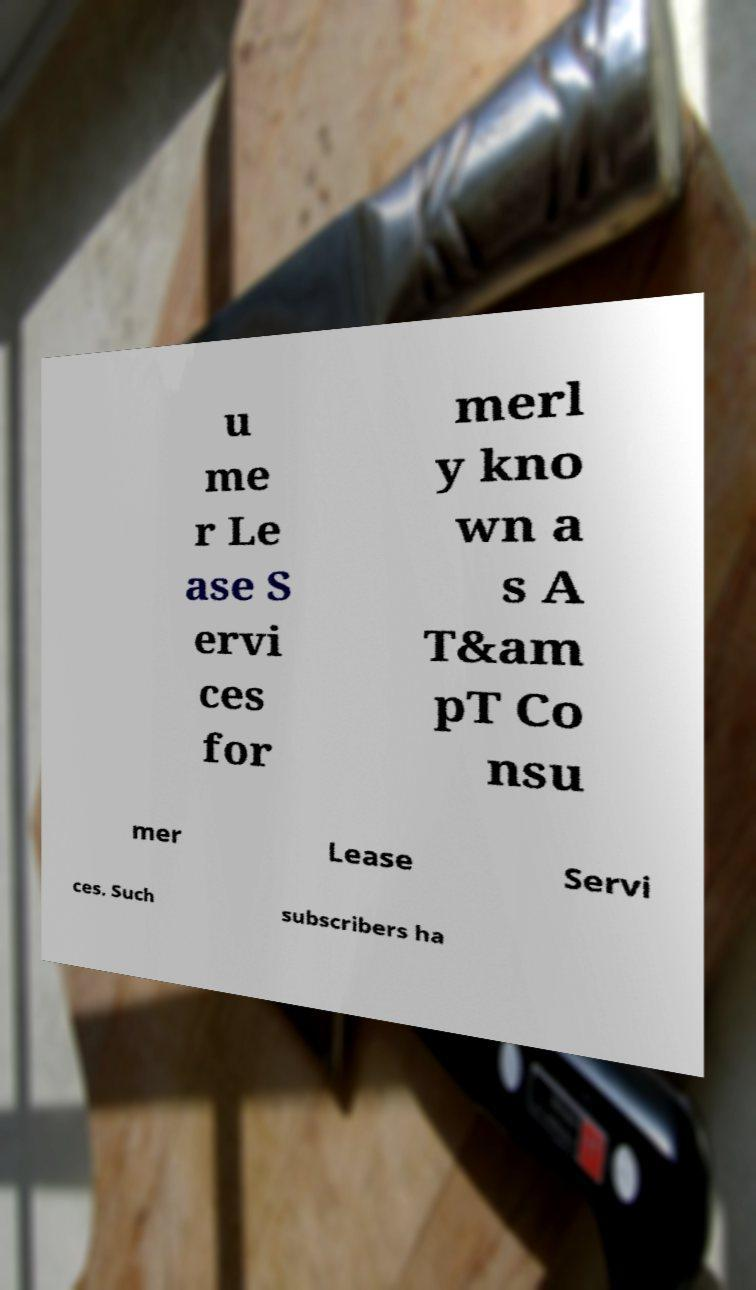Can you accurately transcribe the text from the provided image for me? u me r Le ase S ervi ces for merl y kno wn a s A T&am pT Co nsu mer Lease Servi ces. Such subscribers ha 